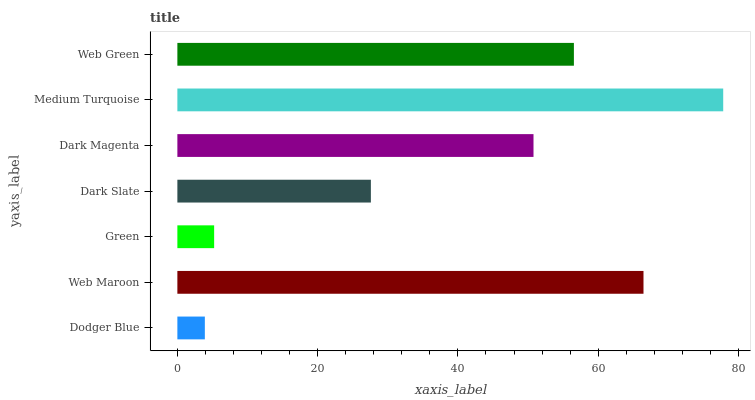Is Dodger Blue the minimum?
Answer yes or no. Yes. Is Medium Turquoise the maximum?
Answer yes or no. Yes. Is Web Maroon the minimum?
Answer yes or no. No. Is Web Maroon the maximum?
Answer yes or no. No. Is Web Maroon greater than Dodger Blue?
Answer yes or no. Yes. Is Dodger Blue less than Web Maroon?
Answer yes or no. Yes. Is Dodger Blue greater than Web Maroon?
Answer yes or no. No. Is Web Maroon less than Dodger Blue?
Answer yes or no. No. Is Dark Magenta the high median?
Answer yes or no. Yes. Is Dark Magenta the low median?
Answer yes or no. Yes. Is Web Green the high median?
Answer yes or no. No. Is Dodger Blue the low median?
Answer yes or no. No. 